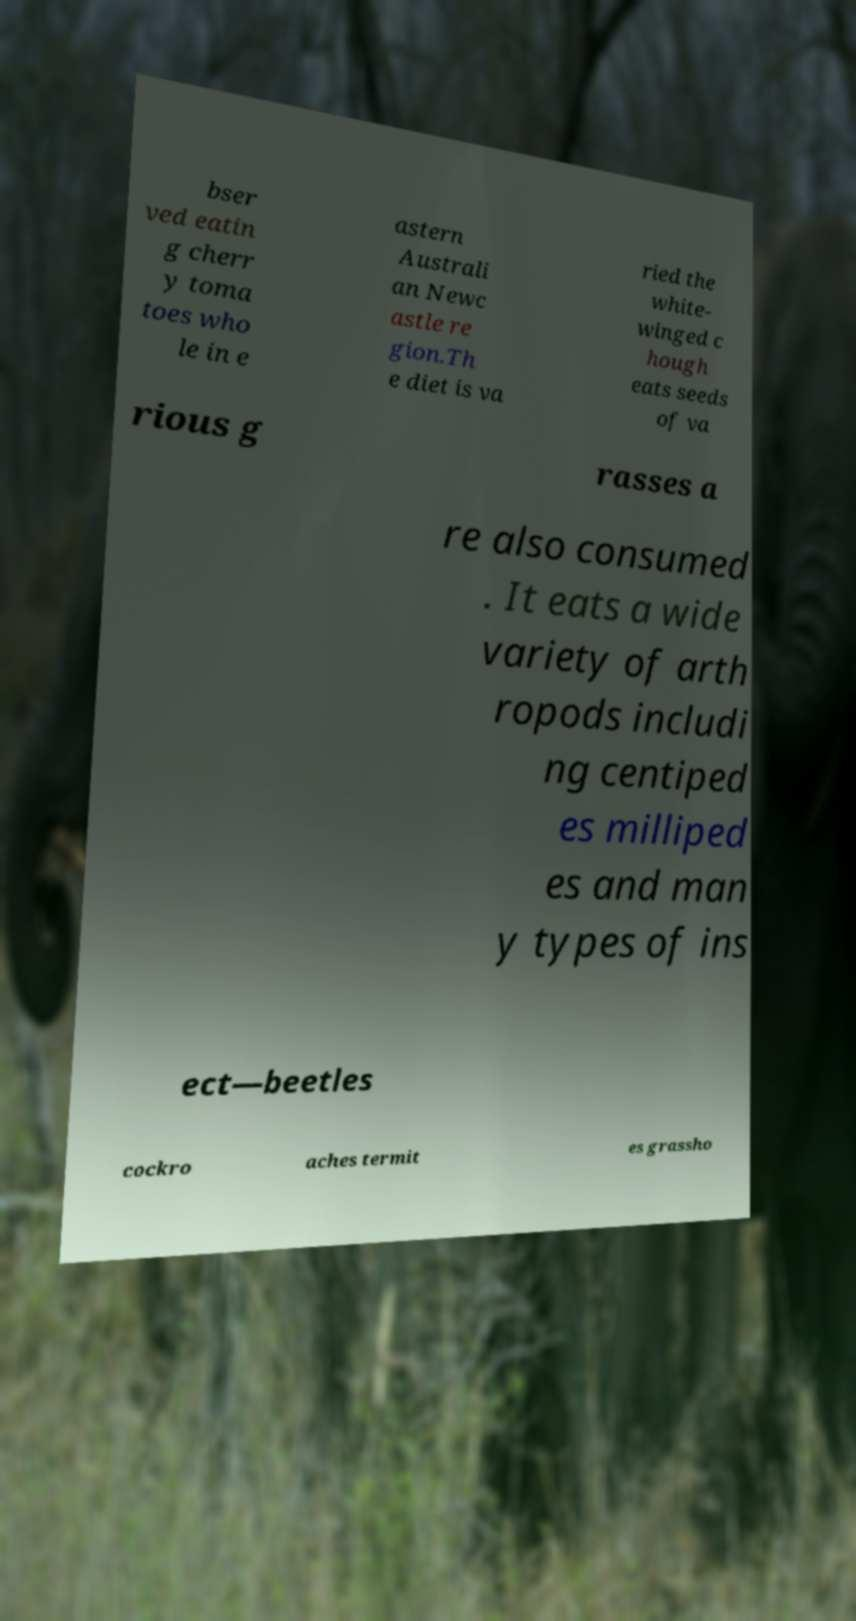For documentation purposes, I need the text within this image transcribed. Could you provide that? bser ved eatin g cherr y toma toes who le in e astern Australi an Newc astle re gion.Th e diet is va ried the white- winged c hough eats seeds of va rious g rasses a re also consumed . It eats a wide variety of arth ropods includi ng centiped es milliped es and man y types of ins ect—beetles cockro aches termit es grassho 